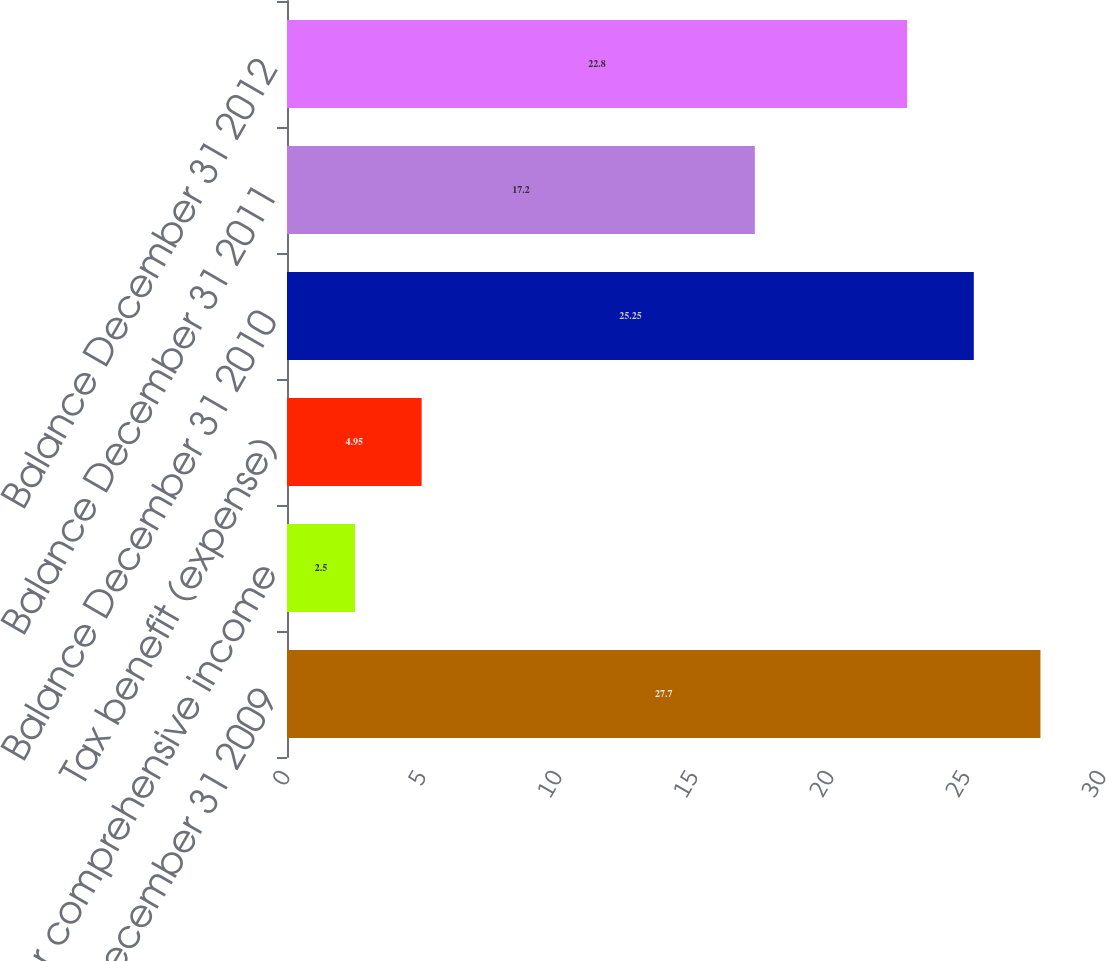Convert chart. <chart><loc_0><loc_0><loc_500><loc_500><bar_chart><fcel>Balance December 31 2009<fcel>Other comprehensive income<fcel>Tax benefit (expense)<fcel>Balance December 31 2010<fcel>Balance December 31 2011<fcel>Balance December 31 2012<nl><fcel>27.7<fcel>2.5<fcel>4.95<fcel>25.25<fcel>17.2<fcel>22.8<nl></chart> 